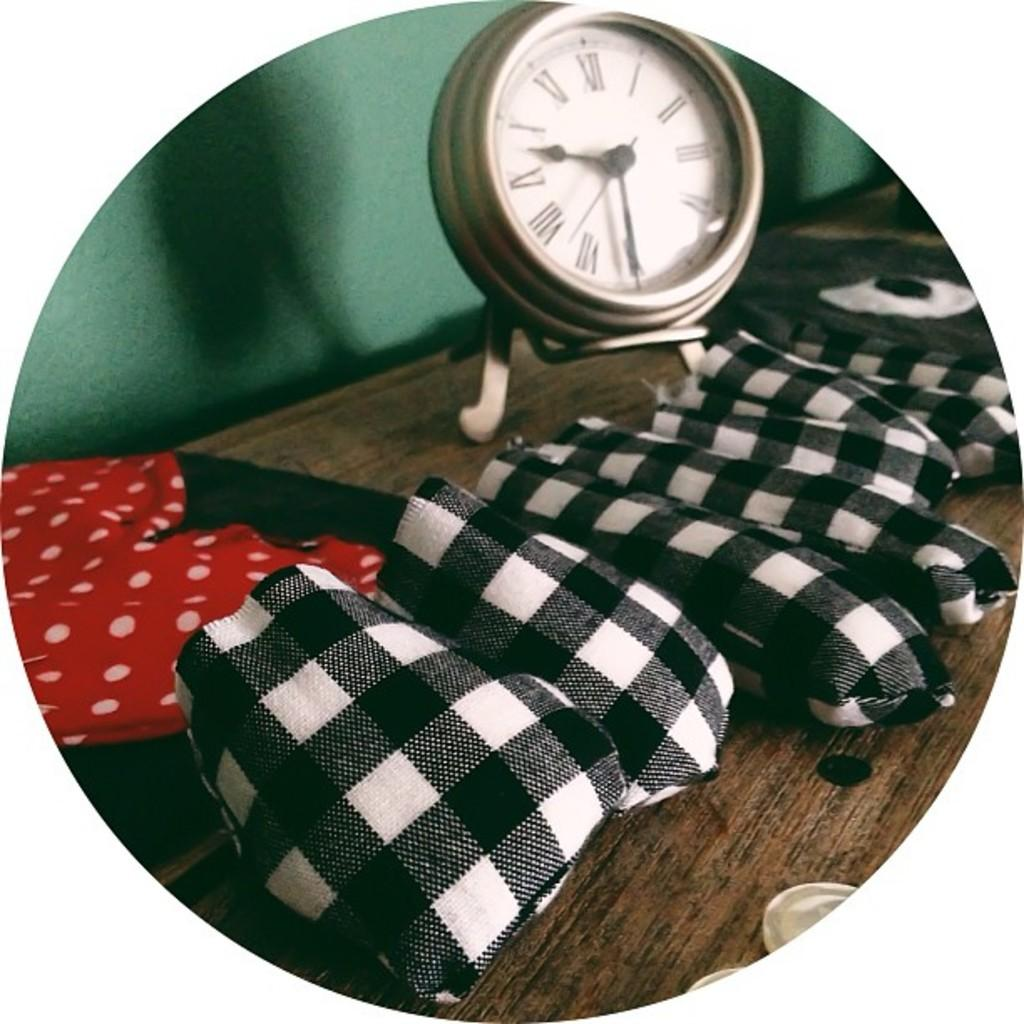<image>
Describe the image concisely. a clock with the roman numeral that is V 